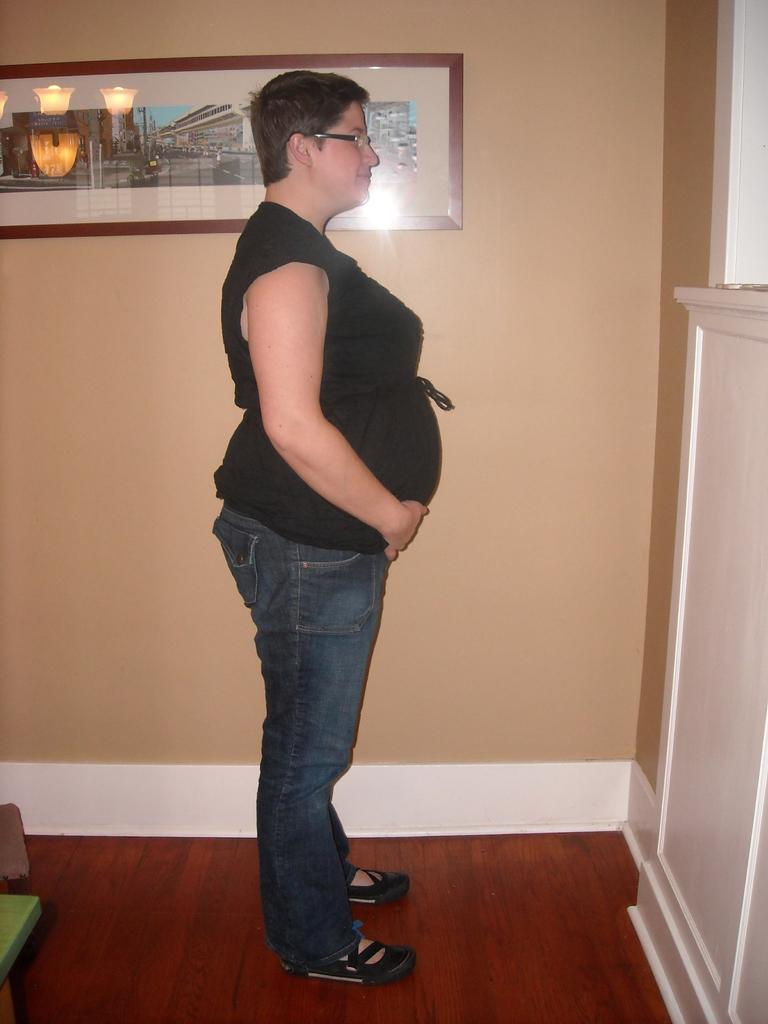What is the main subject of the image? There is a woman standing in the image. Where is the woman standing? The woman is standing on the floor. What else can be seen in the image besides the woman? There are objects visible in the image. What is visible in the background of the image? There is a wall in the background of the image, and there is a frame on the wall. What type of mark can be seen on the notebook in the image? There is no notebook present in the image, so no mark can be observed. 